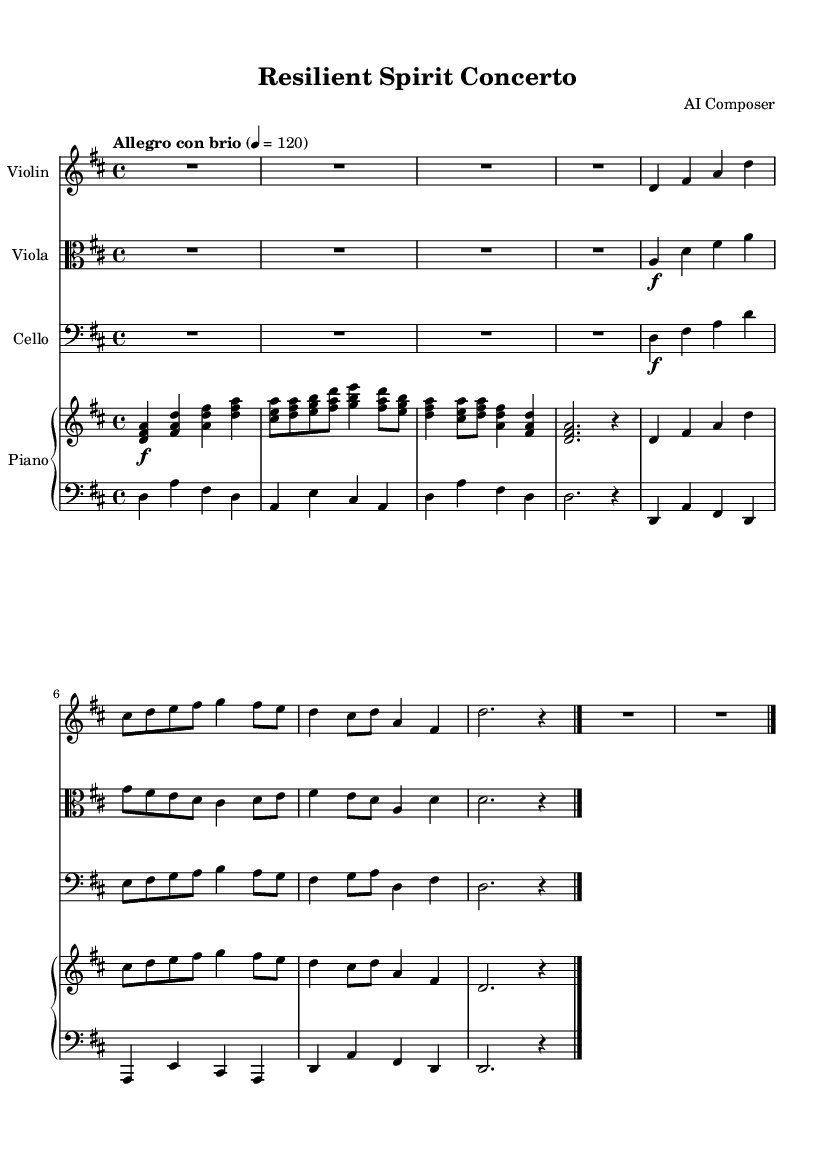What is the key signature of this music? The key signature indicates D major, which contains two sharps (F# and C#). This can be identified in the first line of the sheet music before the staff.
Answer: D major What is the time signature of this music? The time signature shows a 4/4, which means there are four beats in each measure, and the quarter note gets one beat. This is explicitly written at the beginning of the score.
Answer: 4/4 What is the tempo marking given in the sheet music? The tempo marking is "Allegro con brio," denoting a lively and spirited pace for the performance. This is found in the introductory section, just prior to the musical notation.
Answer: Allegro con brio How many measures are in the main theme for the violin? The main theme consists of 4 measures, which can be counted by examining the individual segments separated by the bar lines. The violin's part clearly displays these measures.
Answer: 4 measures What instruments are included in this concerto? The concerto features violin, viola, cello, and piano, as indicated by the different staves each labeled with the corresponding instrument names at the beginning of their respective parts.
Answer: Violin, viola, cello, piano What is the dynamic marking for the viola in the first full section? The dynamic marking for the viola is forte (f), suggesting the passage should be played loudly and with energy. This marking appears next to the note in the first full section of the viola part.
Answer: forte Is there a repeat section in the sheet music? Yes, the repeat is indicated by the bar line notation towards the end of the cello part, demonstrating that a section of music should be played again from the beginning.
Answer: Yes 